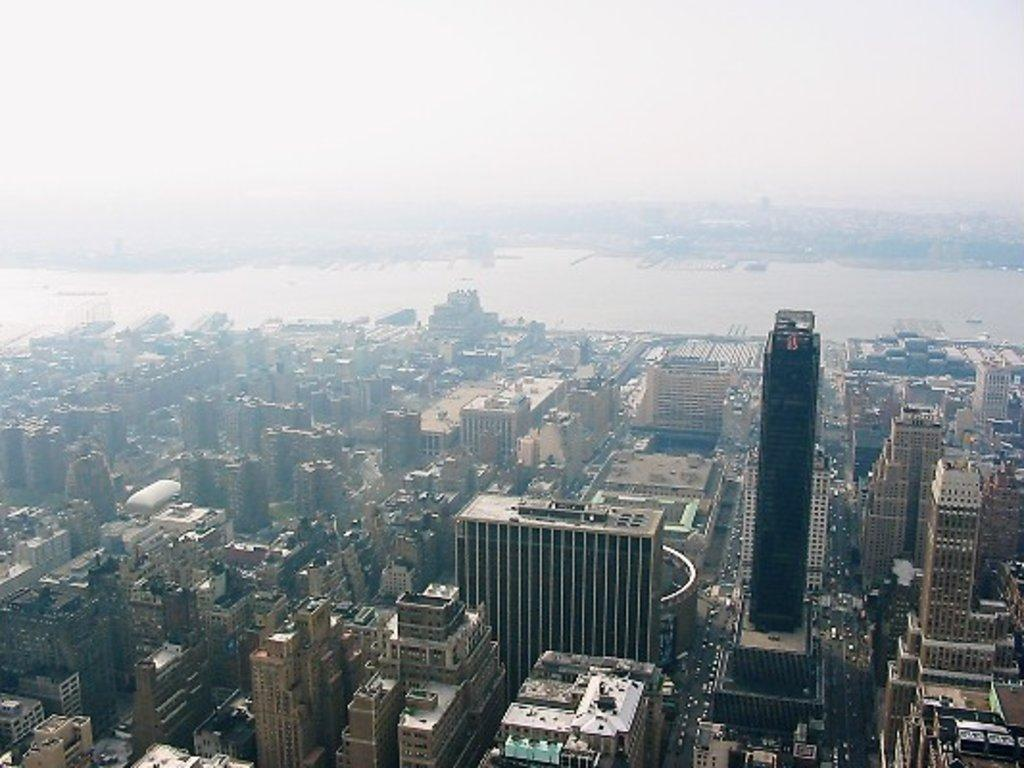What type of structures can be seen in the image? There are buildings in the image. What else is present in the image besides buildings? There are vehicles and water visible in the image. What can be seen in the background of the image? The sky is visible in the background of the image. How many beds can be seen in the image? There are no beds present in the image. What idea is being conveyed by the image? The image does not convey a specific idea; it simply shows buildings, vehicles, water, and the sky. 